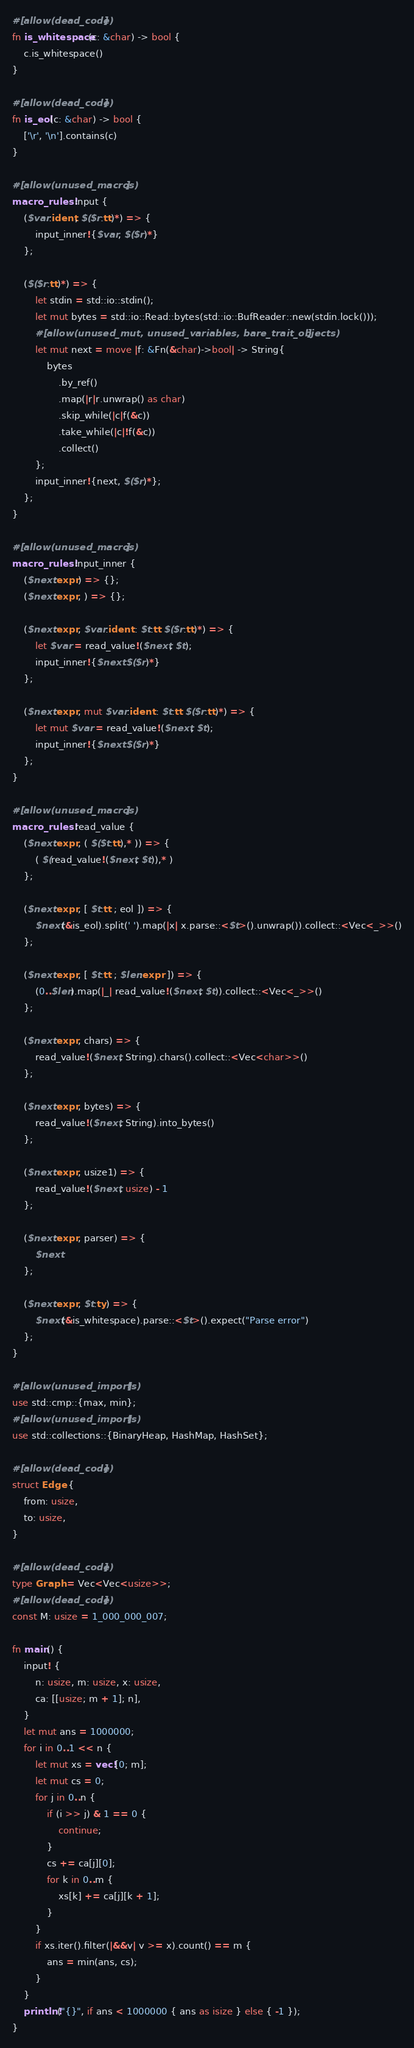<code> <loc_0><loc_0><loc_500><loc_500><_Rust_>#[allow(dead_code)]
fn is_whitespace(c: &char) -> bool {
    c.is_whitespace()
}

#[allow(dead_code)]
fn is_eol(c: &char) -> bool {
    ['\r', '\n'].contains(c)
}

#[allow(unused_macros)]
macro_rules! input {
    ($var:ident, $($r:tt)*) => {
        input_inner!{$var, $($r)*}
    };

    ($($r:tt)*) => {
        let stdin = std::io::stdin();
        let mut bytes = std::io::Read::bytes(std::io::BufReader::new(stdin.lock()));
        #[allow(unused_mut, unused_variables, bare_trait_objects)]
        let mut next = move |f: &Fn(&char)->bool| -> String{
            bytes
                .by_ref()
                .map(|r|r.unwrap() as char)
                .skip_while(|c|f(&c))
                .take_while(|c|!f(&c))
                .collect()
        };
        input_inner!{next, $($r)*};
    };
}

#[allow(unused_macros)]
macro_rules! input_inner {
    ($next:expr) => {};
    ($next:expr, ) => {};

    ($next:expr, $var:ident : $t:tt $($r:tt)*) => {
        let $var = read_value!($next, $t);
        input_inner!{$next $($r)*}
    };

    ($next:expr, mut $var:ident : $t:tt $($r:tt)*) => {
        let mut $var = read_value!($next, $t);
        input_inner!{$next $($r)*}
    };
}

#[allow(unused_macros)]
macro_rules! read_value {
    ($next:expr, ( $($t:tt),* )) => {
        ( $(read_value!($next, $t)),* )
    };

    ($next:expr, [ $t:tt ; eol ]) => {
        $next(&is_eol).split(' ').map(|x| x.parse::<$t>().unwrap()).collect::<Vec<_>>()
    };

    ($next:expr, [ $t:tt ; $len:expr ]) => {
        (0..$len).map(|_| read_value!($next, $t)).collect::<Vec<_>>()
    };

    ($next:expr, chars) => {
        read_value!($next, String).chars().collect::<Vec<char>>()
    };

    ($next:expr, bytes) => {
        read_value!($next, String).into_bytes()
    };

    ($next:expr, usize1) => {
        read_value!($next, usize) - 1
    };

    ($next:expr, parser) => {
        $next
    };

    ($next:expr, $t:ty) => {
        $next(&is_whitespace).parse::<$t>().expect("Parse error")
    };
}

#[allow(unused_imports)]
use std::cmp::{max, min};
#[allow(unused_imports)]
use std::collections::{BinaryHeap, HashMap, HashSet};

#[allow(dead_code)]
struct Edge {
    from: usize,
    to: usize,
}

#[allow(dead_code)]
type Graph = Vec<Vec<usize>>;
#[allow(dead_code)]
const M: usize = 1_000_000_007;

fn main() {
    input! {
        n: usize, m: usize, x: usize,
        ca: [[usize; m + 1]; n],
    }
    let mut ans = 1000000;
    for i in 0..1 << n {
        let mut xs = vec![0; m];
        let mut cs = 0;
        for j in 0..n {
            if (i >> j) & 1 == 0 {
                continue;
            }
            cs += ca[j][0];
            for k in 0..m {
                xs[k] += ca[j][k + 1];
            }
        }
        if xs.iter().filter(|&&v| v >= x).count() == m {
            ans = min(ans, cs);
        }
    }
    println!("{}", if ans < 1000000 { ans as isize } else { -1 });
}
</code> 